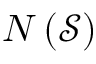<formula> <loc_0><loc_0><loc_500><loc_500>N \left ( { \mathcal { S } } \right )</formula> 